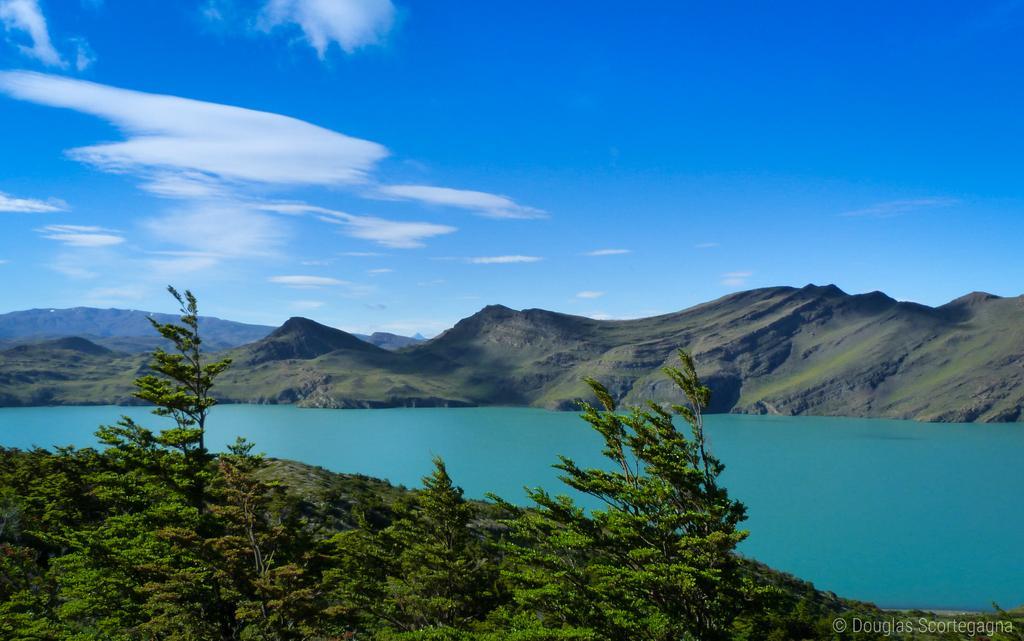In one or two sentences, can you explain what this image depicts? In this image we can see some trees and there is a lake in the center of the image and in the background, we can see the mountains and at the top, we can see the sky with clouds. 